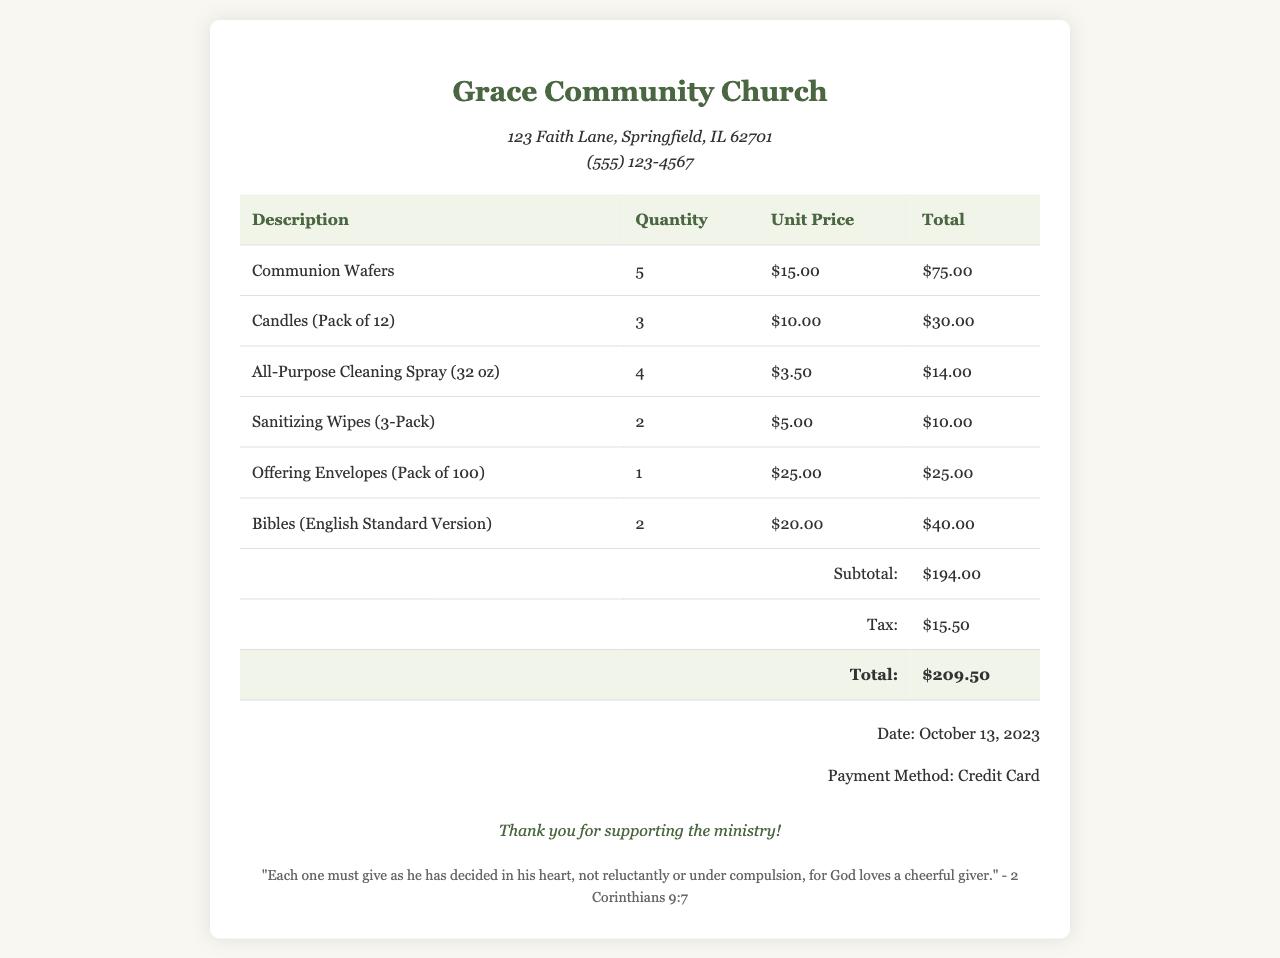What is the total amount spent on communion wafers? The total amount spent on communion wafers is found in the total column for that item, which is $75.00.
Answer: $75.00 How many candles were purchased? The quantity of candles purchased is listed in the quantity column for that item, which is 3.
Answer: 3 What is the subtotal amount before tax? The subtotal is listed at the bottom of the itemized table before tax calculations, which is $194.00.
Answer: $194.00 What is the date of the purchase? The date of the purchase is mentioned in the payment info section, which is October 13, 2023.
Answer: October 13, 2023 What is the total cost after tax? The total cost after tax is calculated from the subtotal plus tax, and it is displayed at the end of the table, which is $209.50.
Answer: $209.50 How many Bibles were purchased? The number of Bibles purchased can be found in the quantity column for that item, which is 2.
Answer: 2 What was the payment method used? The payment method is listed in the payment info section, which indicates it was a credit card.
Answer: Credit Card What type of cleaning products were bought? The type of cleaning products includes All-Purpose Cleaning Spray and Sanitizing Wipes, both listed in the itemized table.
Answer: All-Purpose Cleaning Spray, Sanitizing Wipes What is the church's address? The church's address can be found at the top of the receipt, listed as 123 Faith Lane, Springfield, IL 62701.
Answer: 123 Faith Lane, Springfield, IL 62701 